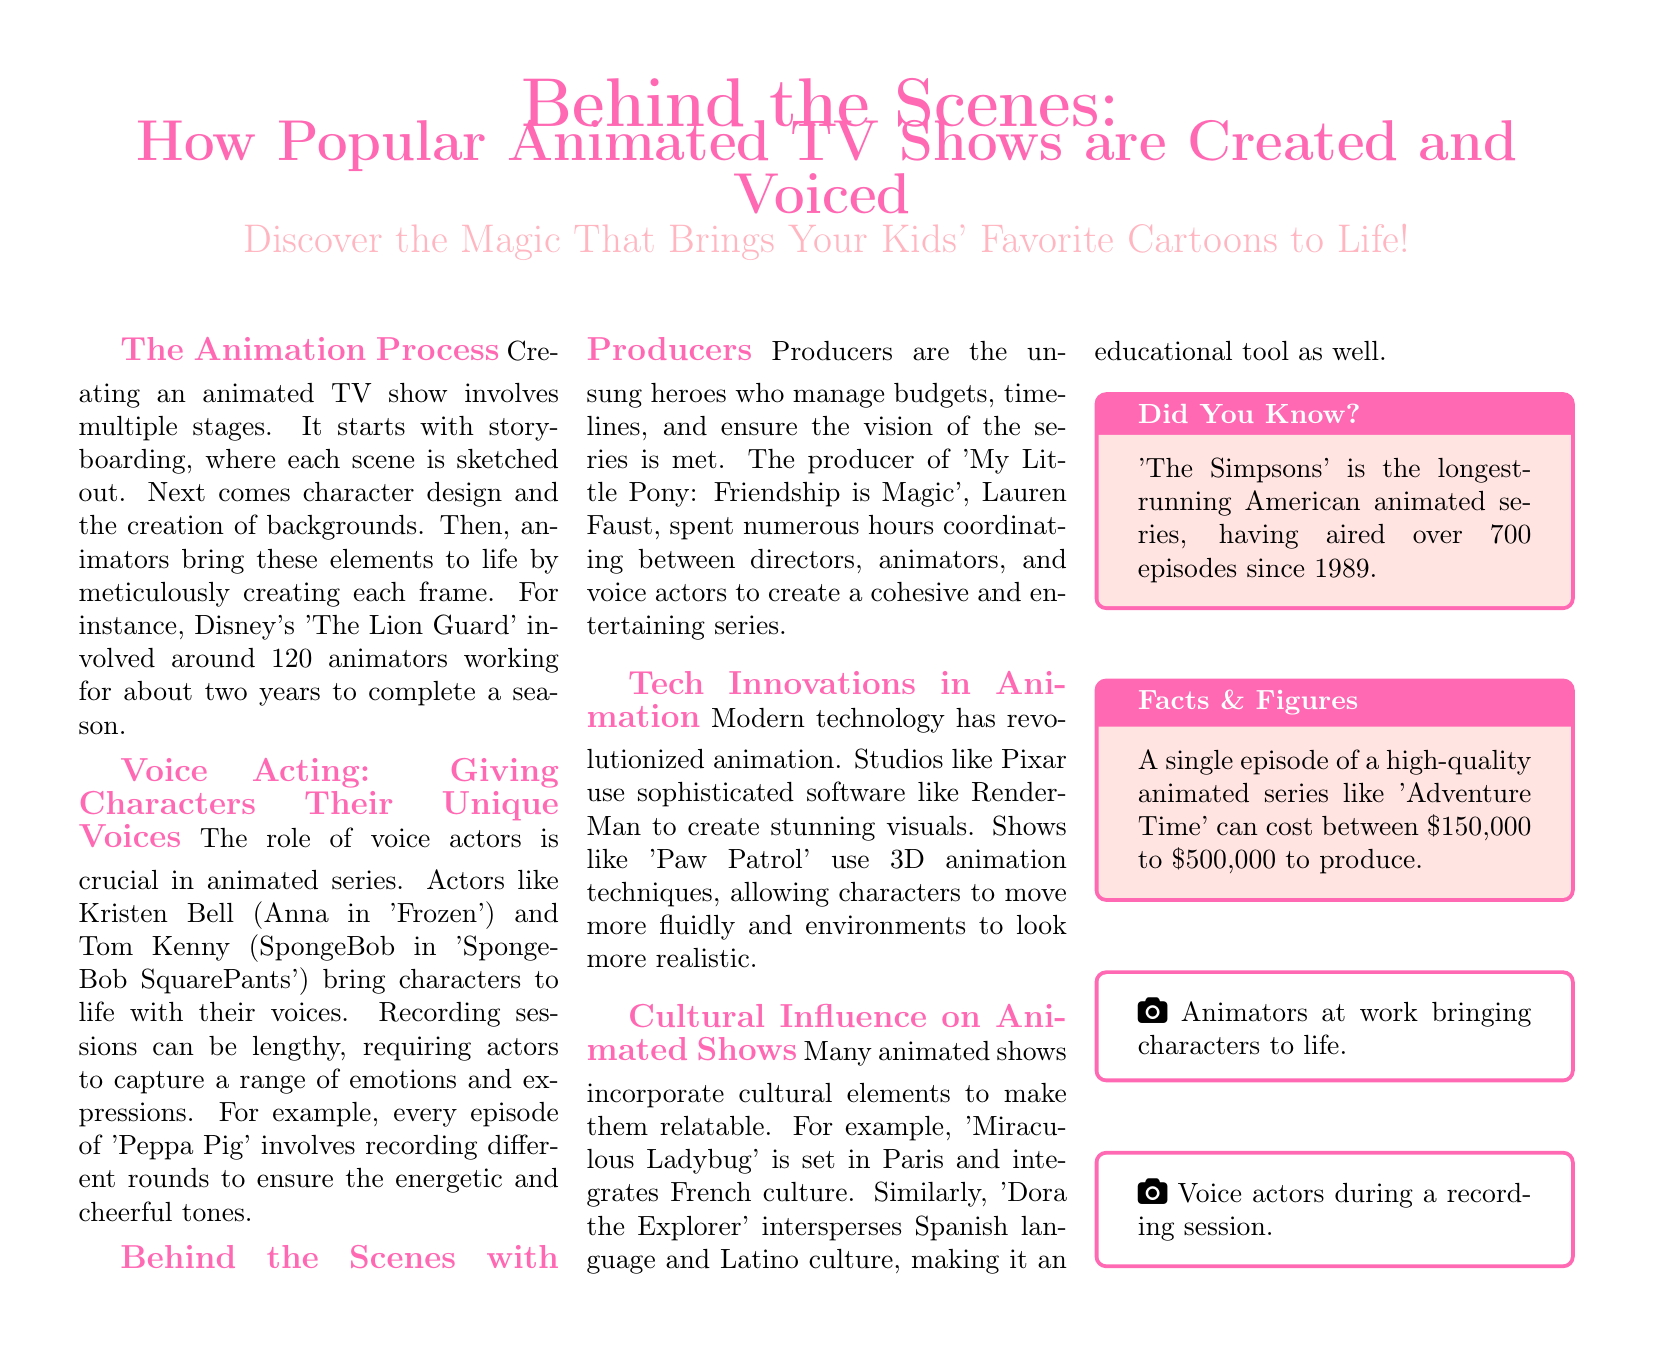What is the primary focus of the document? The primary focus of the document is to explain the process of creating and voicing popular animated TV shows, as outlined in both the title and the subheadline.
Answer: Animated TV shows How many animators worked on 'The Lion Guard'? The document states that around 120 animators worked on 'The Lion Guard' for about two years to complete a season.
Answer: 120 animators Who is the voice actor for Anna in 'Frozen'? The document mentions Kristen Bell as the voice actor for Anna in 'Frozen'.
Answer: Kristen Bell What is the purpose of having producers in animated series? The document explains that producers manage budgets, timelines, and coordinate between different teams to ensure the vision of the series is met.
Answer: Manage budgets Which software does Pixar use for animation? The document indicates that Pixar uses sophisticated software called RenderMan for creating visuals.
Answer: RenderMan How much can a single episode of 'Adventure Time' cost to produce? According to the document, producing a single episode of 'Adventure Time' can cost between $150,000 to $500,000.
Answer: $150,000 to $500,000 What unique cultural aspect is included in 'Dora the Explorer'? The document states that 'Dora the Explorer' incorporates Spanish language and Latino culture as an educational tool.
Answer: Spanish language What is the longest-running American animated series? The document notes that 'The Simpsons' is the longest-running American animated series.
Answer: The Simpsons Who is the producer of 'My Little Pony: Friendship is Magic'? The document identifies Lauren Faust as the producer of 'My Little Pony: Friendship is Magic'.
Answer: Lauren Faust 